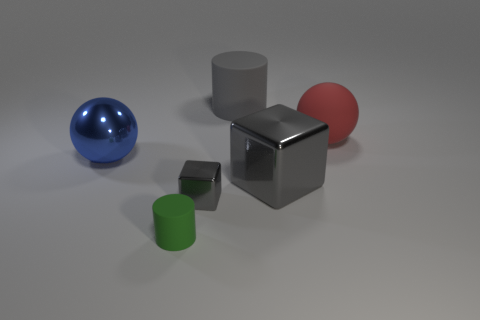There is a large thing that is the same color as the big cylinder; what is its shape?
Your response must be concise. Cube. What is the material of the red object?
Provide a succinct answer. Rubber. Is the material of the red object the same as the tiny cube?
Provide a short and direct response. No. How many metal objects are large blue objects or tiny cubes?
Keep it short and to the point. 2. There is a large rubber thing that is behind the red matte thing; what shape is it?
Your answer should be compact. Cylinder. The ball that is the same material as the gray cylinder is what size?
Your response must be concise. Large. There is a thing that is both to the right of the gray cylinder and left of the large rubber ball; what shape is it?
Give a very brief answer. Cube. There is a large sphere on the left side of the big gray cylinder; is it the same color as the tiny rubber cylinder?
Your answer should be compact. No. There is a big gray object that is behind the big shiny sphere; does it have the same shape as the big gray thing that is in front of the large red matte sphere?
Your response must be concise. No. There is a cylinder in front of the big blue sphere; what is its size?
Provide a short and direct response. Small. 